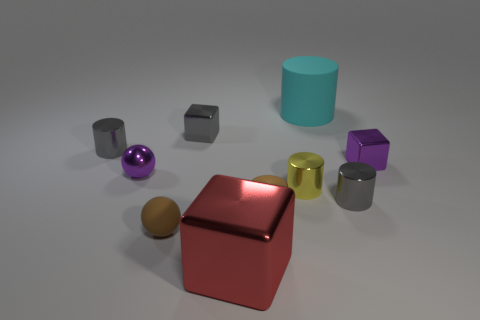Subtract all small brown cylinders. How many cylinders are left? 4 Subtract 2 cylinders. How many cylinders are left? 3 Subtract all cyan cubes. Subtract all green spheres. How many cubes are left? 3 Subtract all balls. How many objects are left? 8 Add 9 tiny matte spheres. How many tiny matte spheres exist? 10 Subtract 0 green balls. How many objects are left? 10 Subtract all big gray shiny blocks. Subtract all red objects. How many objects are left? 9 Add 8 tiny purple metallic blocks. How many tiny purple metallic blocks are left? 9 